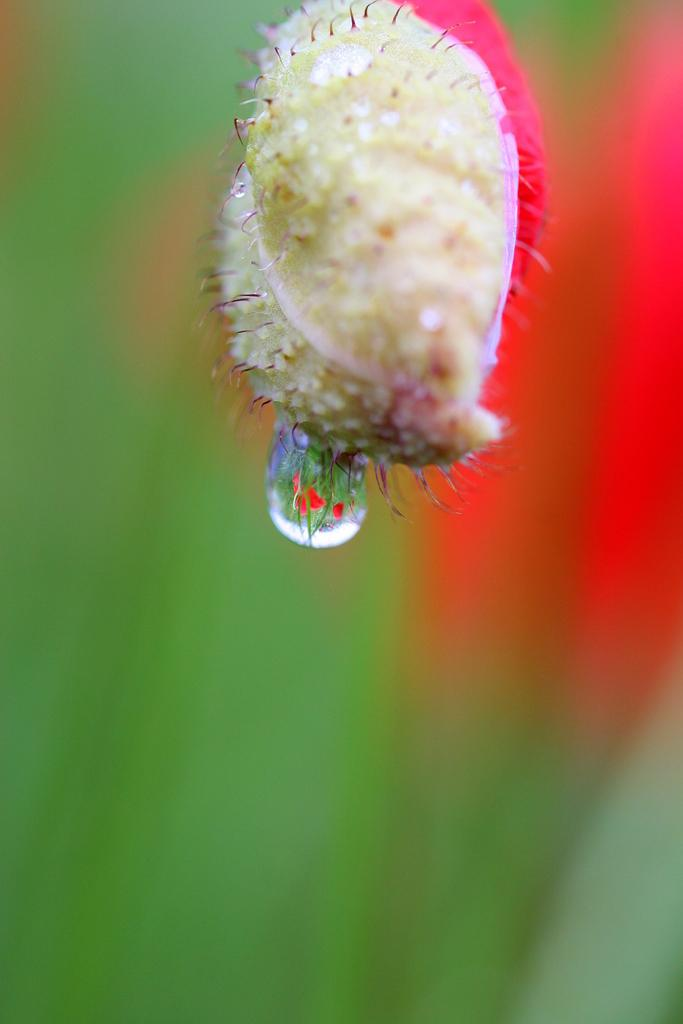What is the main subject of the image? The main subject of the image is a dew drop on a flower. Can you describe the dew drop in the image? The dew drop is a small droplet of water on the surface of the flower. What type of flower is the dew drop on? The specific type of flower cannot be determined from the image. What type of selection process is being used by the band in the image? There is no band present in the image; it features a dew drop on a flower. 